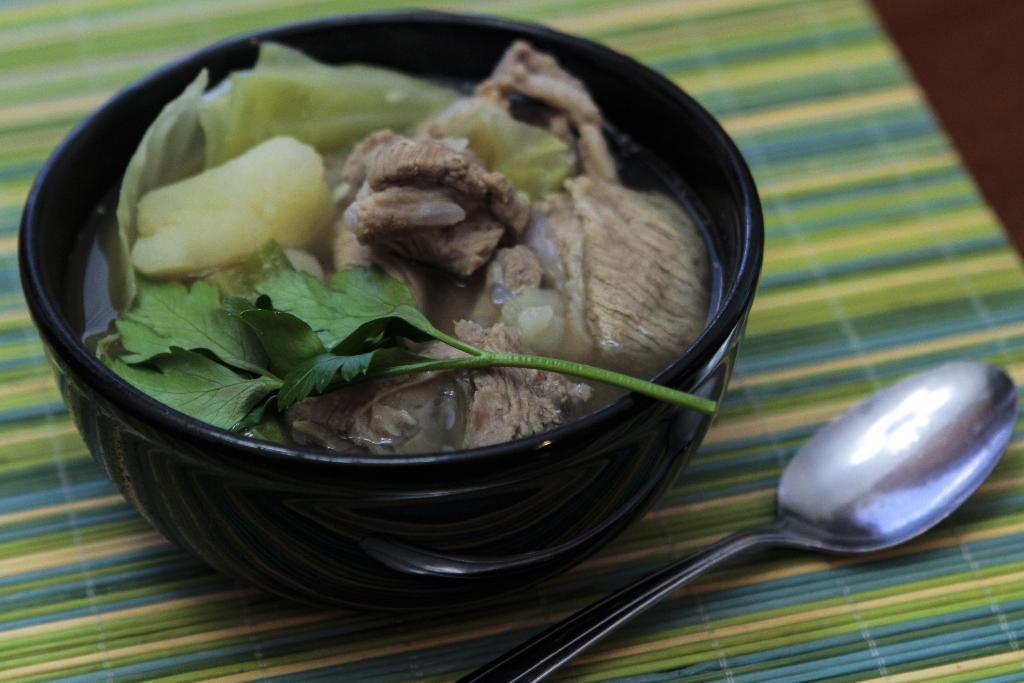Can you describe this image briefly? In the image there is some cooked food item served in a bowl and beside the bowl there is a spoon. 